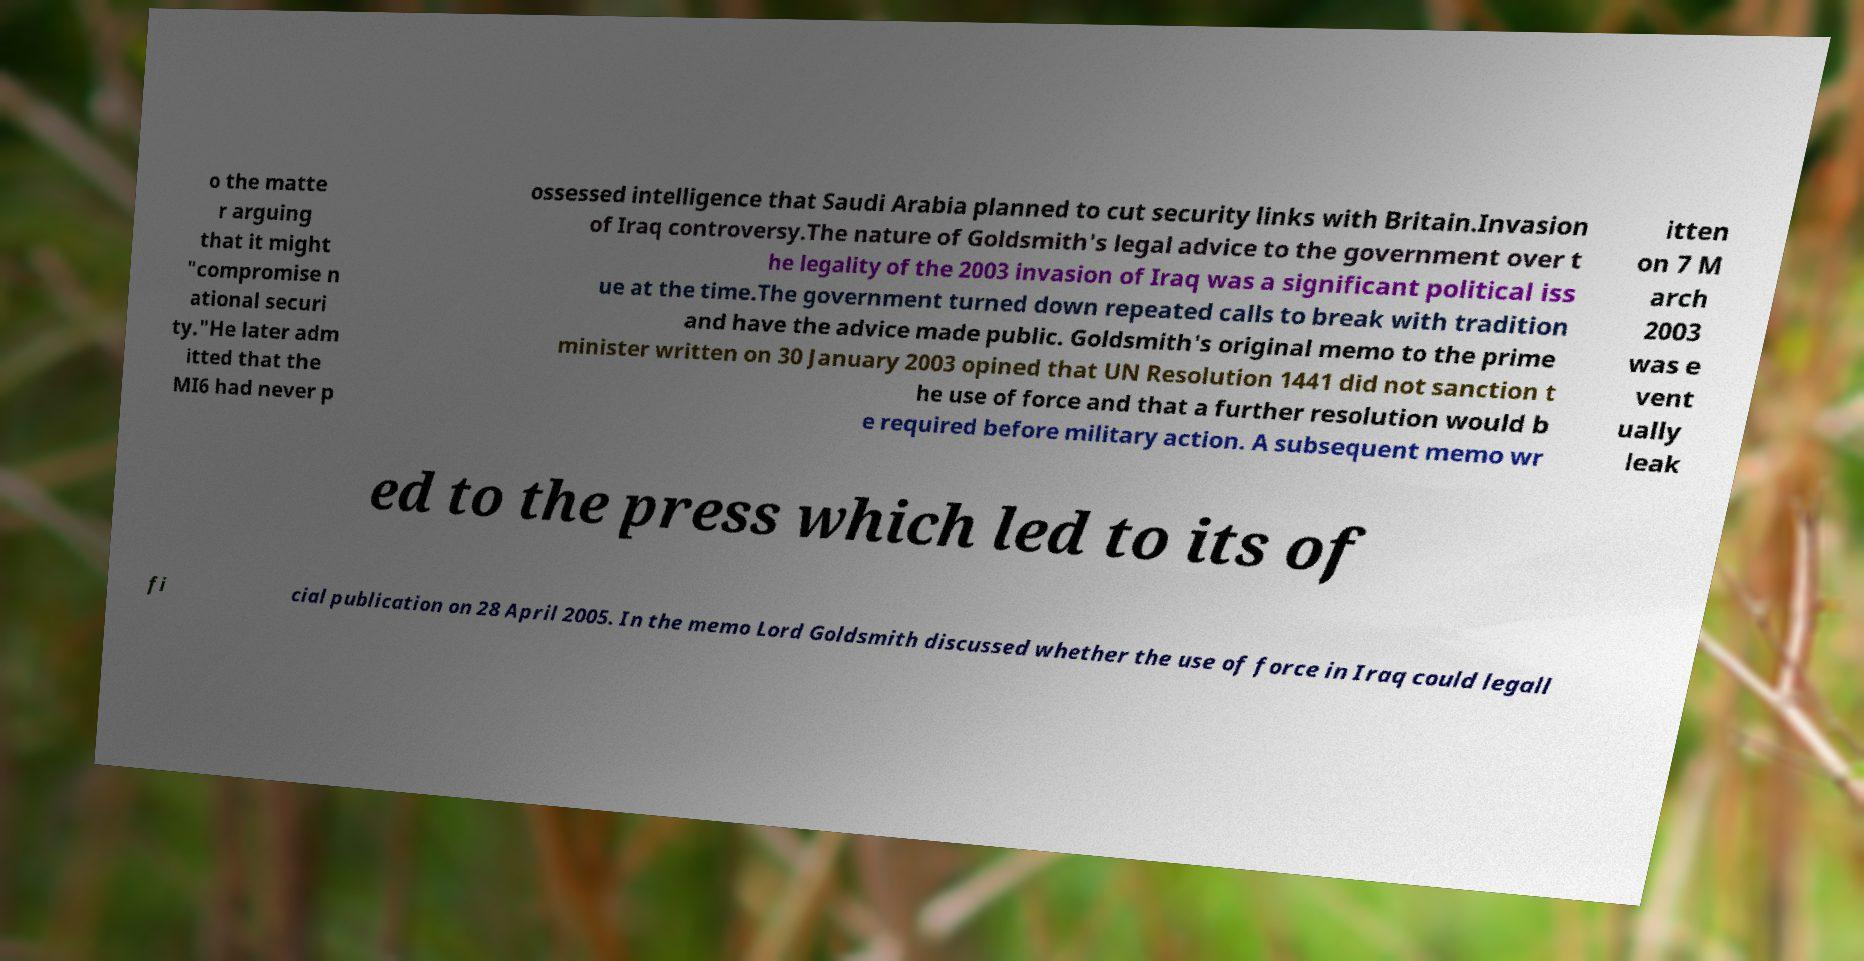Could you assist in decoding the text presented in this image and type it out clearly? o the matte r arguing that it might "compromise n ational securi ty."He later adm itted that the MI6 had never p ossessed intelligence that Saudi Arabia planned to cut security links with Britain.Invasion of Iraq controversy.The nature of Goldsmith's legal advice to the government over t he legality of the 2003 invasion of Iraq was a significant political iss ue at the time.The government turned down repeated calls to break with tradition and have the advice made public. Goldsmith's original memo to the prime minister written on 30 January 2003 opined that UN Resolution 1441 did not sanction t he use of force and that a further resolution would b e required before military action. A subsequent memo wr itten on 7 M arch 2003 was e vent ually leak ed to the press which led to its of fi cial publication on 28 April 2005. In the memo Lord Goldsmith discussed whether the use of force in Iraq could legall 